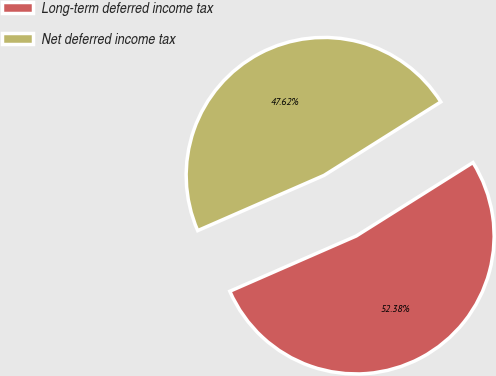Convert chart. <chart><loc_0><loc_0><loc_500><loc_500><pie_chart><fcel>Long-term deferred income tax<fcel>Net deferred income tax<nl><fcel>52.38%<fcel>47.62%<nl></chart> 